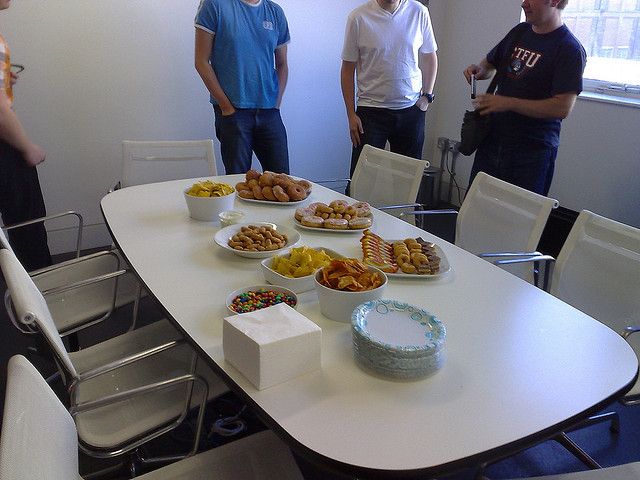Please transcribe the text information in this image. TFU 